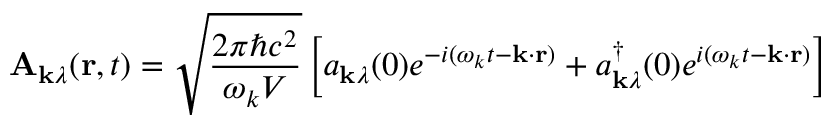<formula> <loc_0><loc_0><loc_500><loc_500>A _ { k \lambda } ( r , t ) = { \sqrt { \frac { 2 \pi \hbar { c } ^ { 2 } } { \omega _ { k } V } } } \left [ a _ { k \lambda } ( 0 ) e ^ { - i ( \omega _ { k } t - k \cdot r ) } + a _ { k \lambda } ^ { \dagger } ( 0 ) e ^ { i ( \omega _ { k } t - k \cdot r ) } \right ]</formula> 